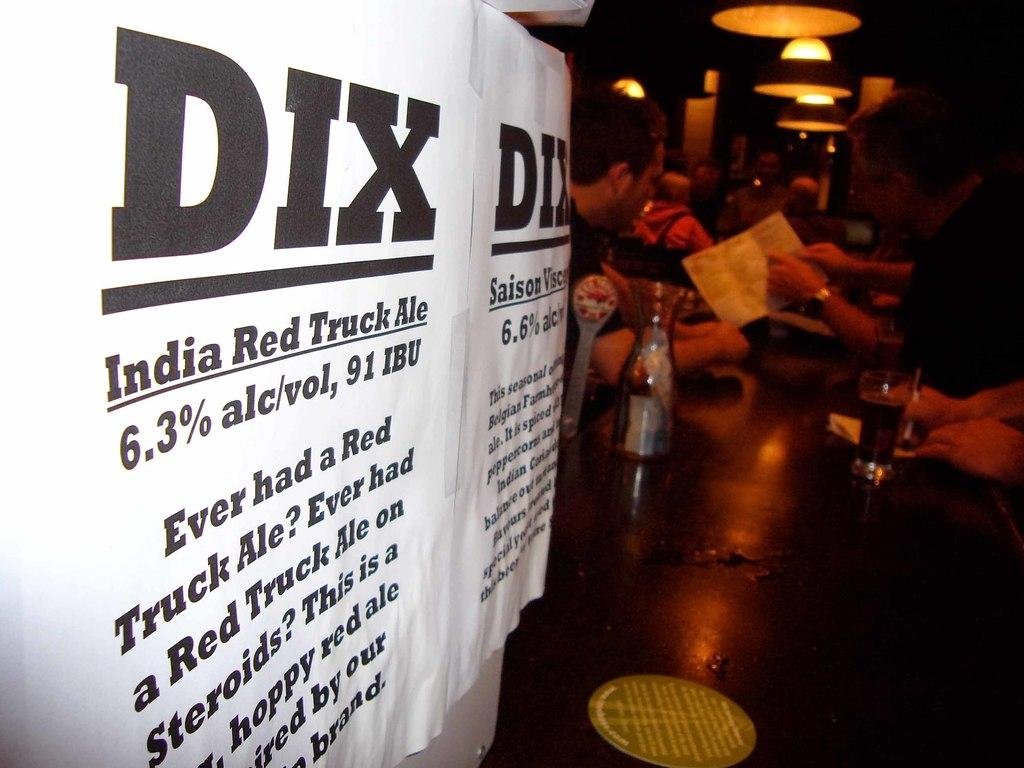<image>
Present a compact description of the photo's key features. A sign on a table advertising India Red Truck Ale. 